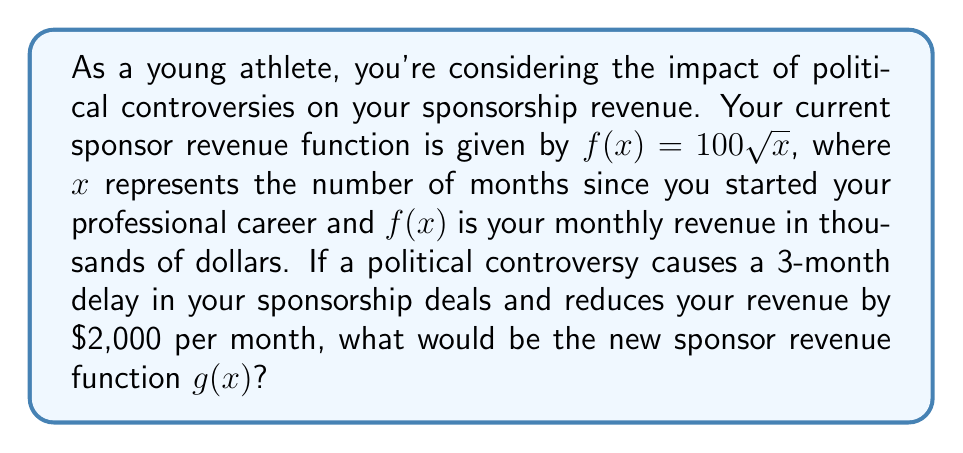Help me with this question. To solve this problem, we need to apply both horizontal and vertical shifts to the original function. Let's break it down step-by-step:

1. The original function is $f(x) = 100\sqrt{x}$

2. The political controversy causes a 3-month delay in sponsorship deals. This means we need to shift the function 3 units to the right. To do this, we replace $x$ with $(x-3)$:
   $f(x-3) = 100\sqrt{x-3}$

3. The controversy also reduces revenue by $2,000 per month. Since our function is in thousands of dollars, this is a reduction of 2 units. We need to shift the function 2 units down. To do this, we subtract 2 from the entire function:
   $100\sqrt{x-3} - 2$

4. Combining these transformations, we get our new function $g(x)$:
   $g(x) = 100\sqrt{x-3} - 2$

This new function $g(x)$ represents the sponsor revenue after the political controversy, taking into account both the delay in deals and the reduction in monthly revenue.
Answer: $g(x) = 100\sqrt{x-3} - 2$ 